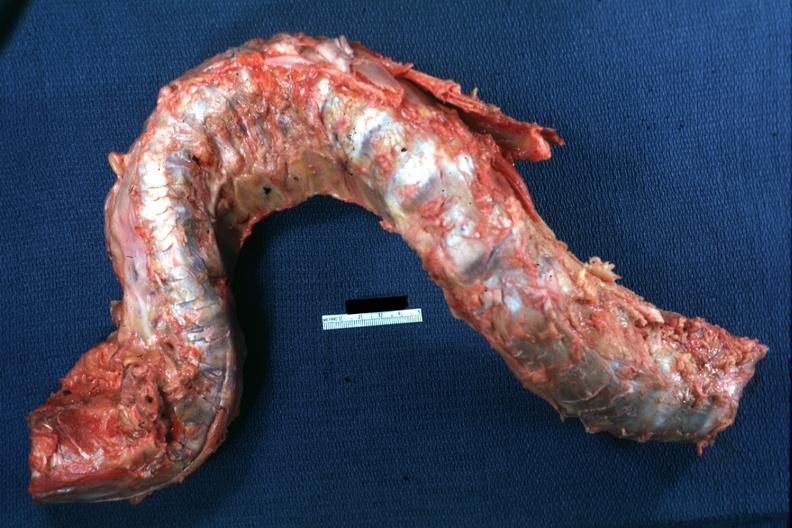what does this image show?
Answer the question using a single word or phrase. Excised spinal column grossly deformed 